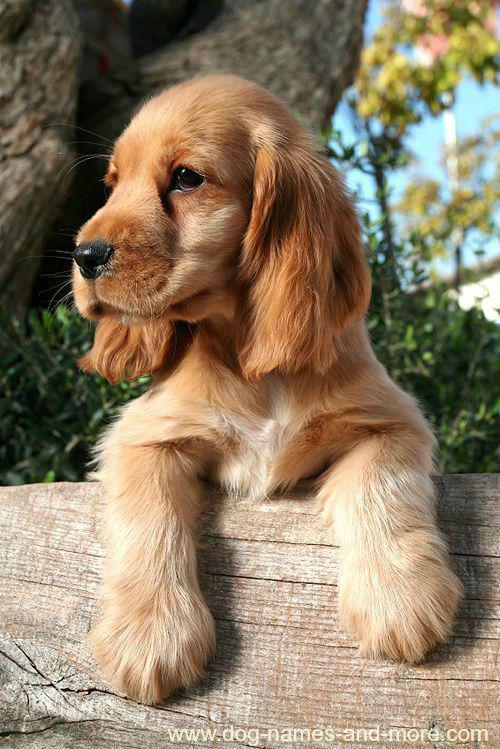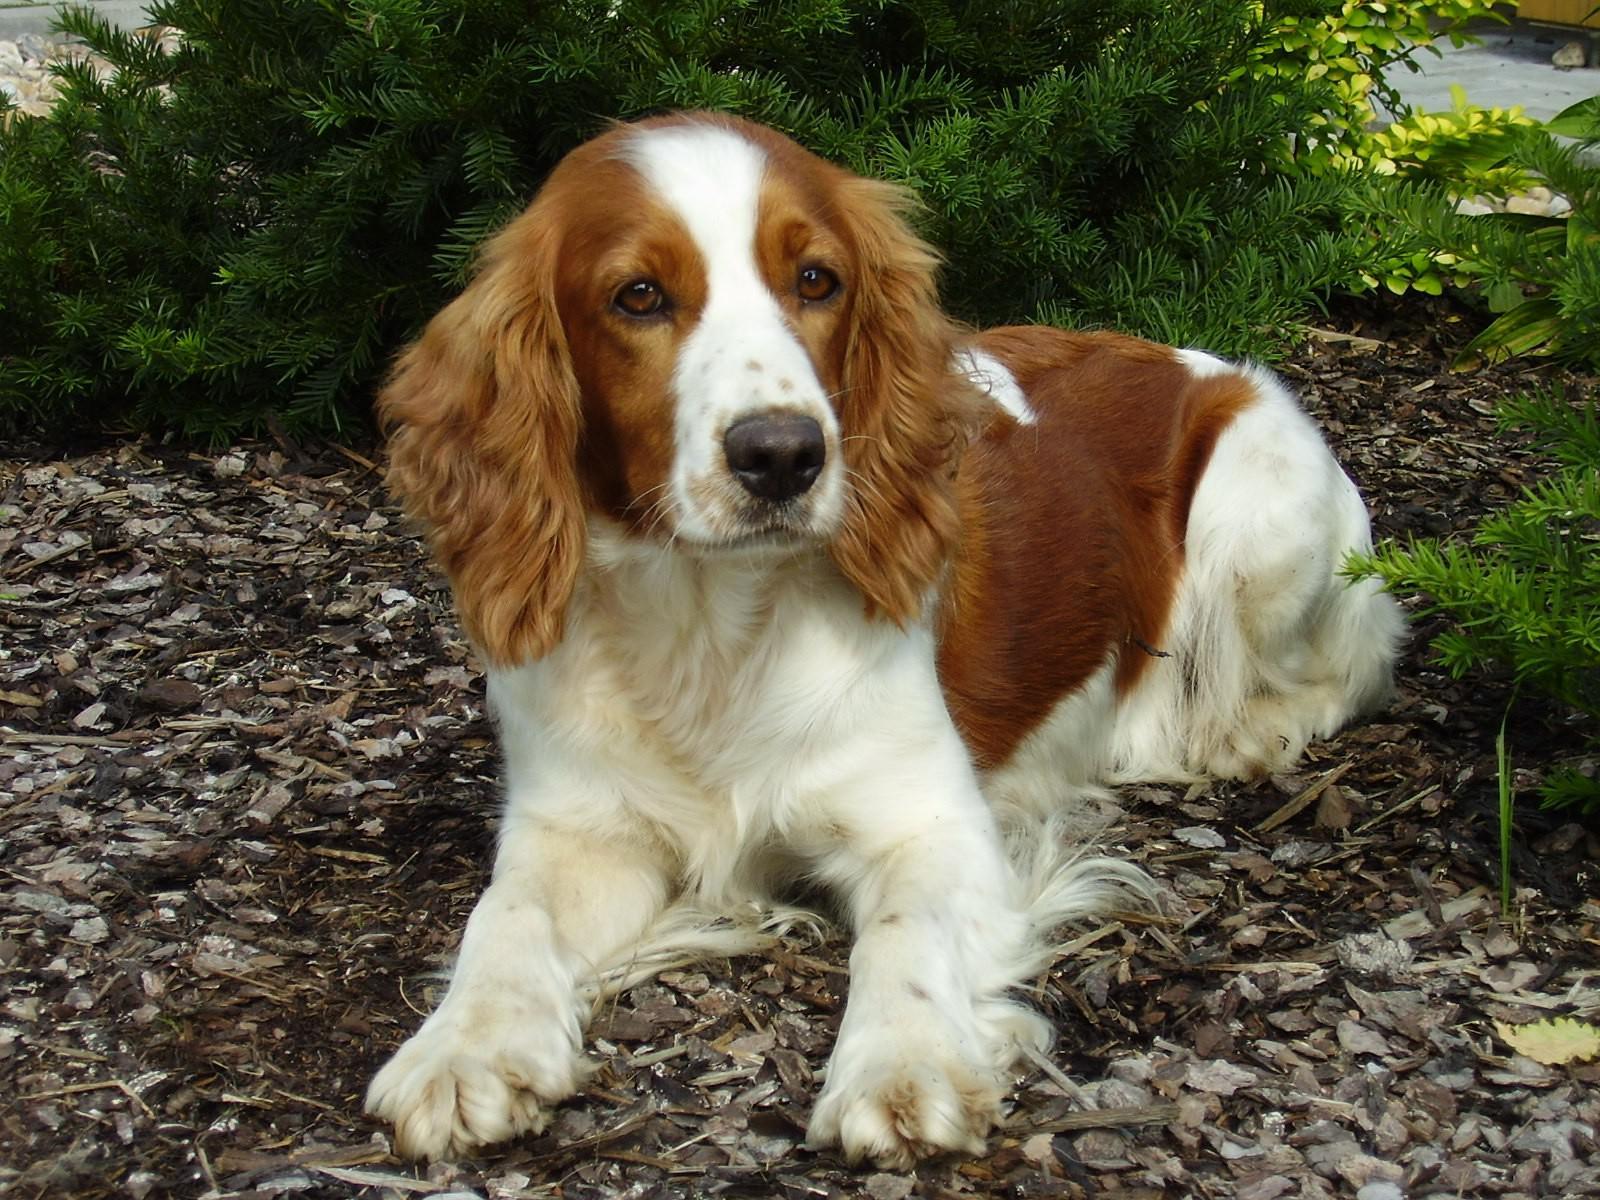The first image is the image on the left, the second image is the image on the right. Assess this claim about the two images: "In one of the images the dog is lying down.". Correct or not? Answer yes or no. Yes. 